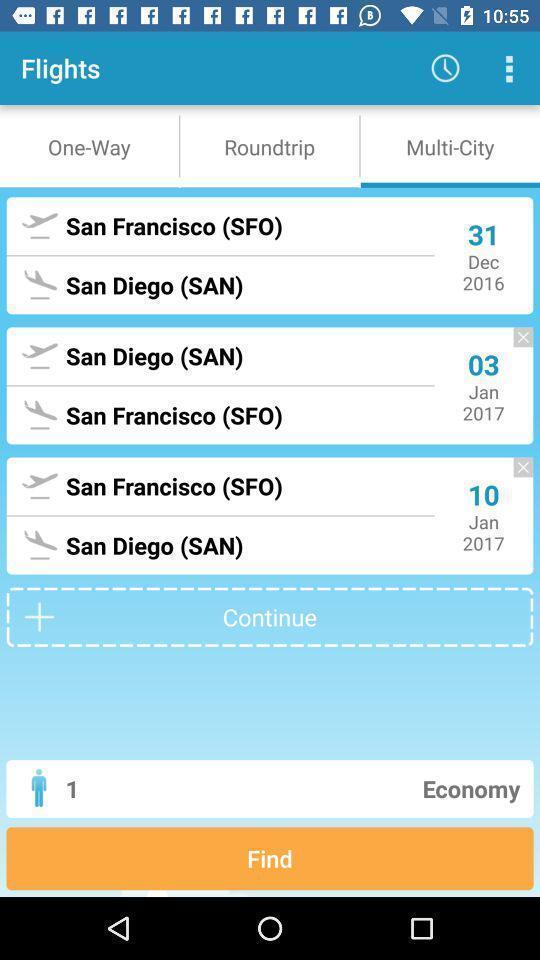Provide a description of this screenshot. Screen showing dates for availability of flights of travel app. 